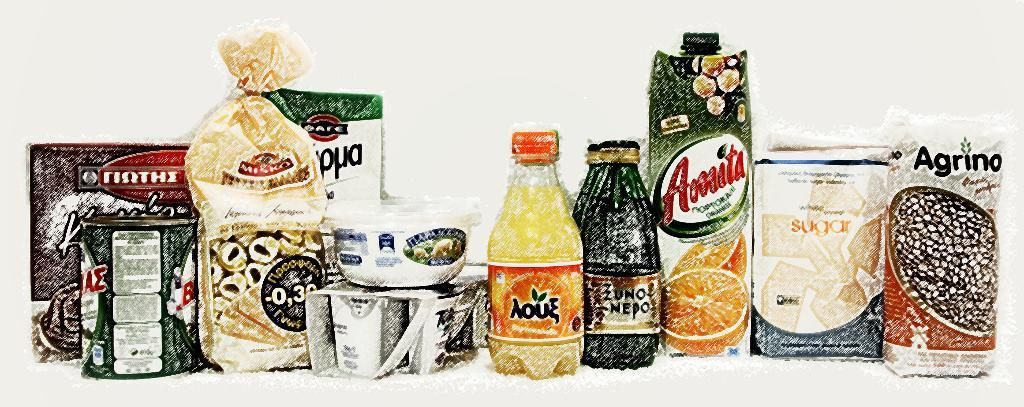<image>
Summarize the visual content of the image. a row of food with one labeled 'agrino' 